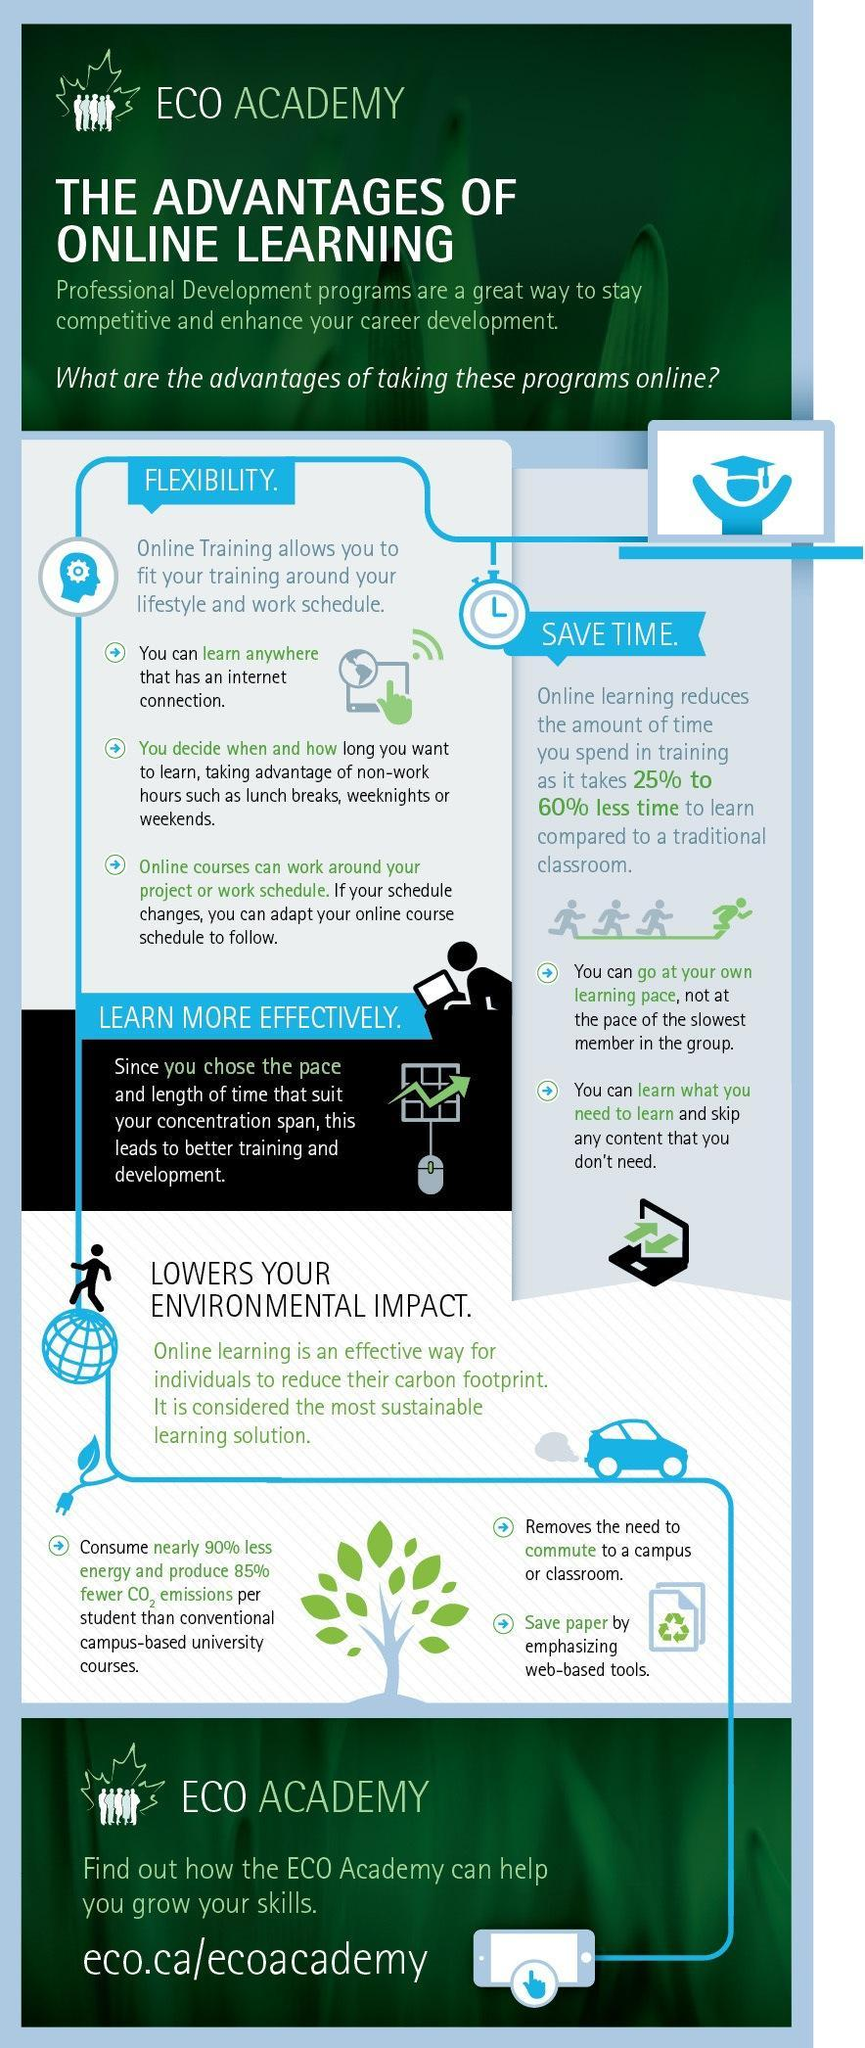How many advantages does a student have due to online learning?
Answer the question with a short phrase. 4 What percentage of time is saved due to online learning, 80%- 85%, 25%-60%, or 85%-90%? 25%-60% 